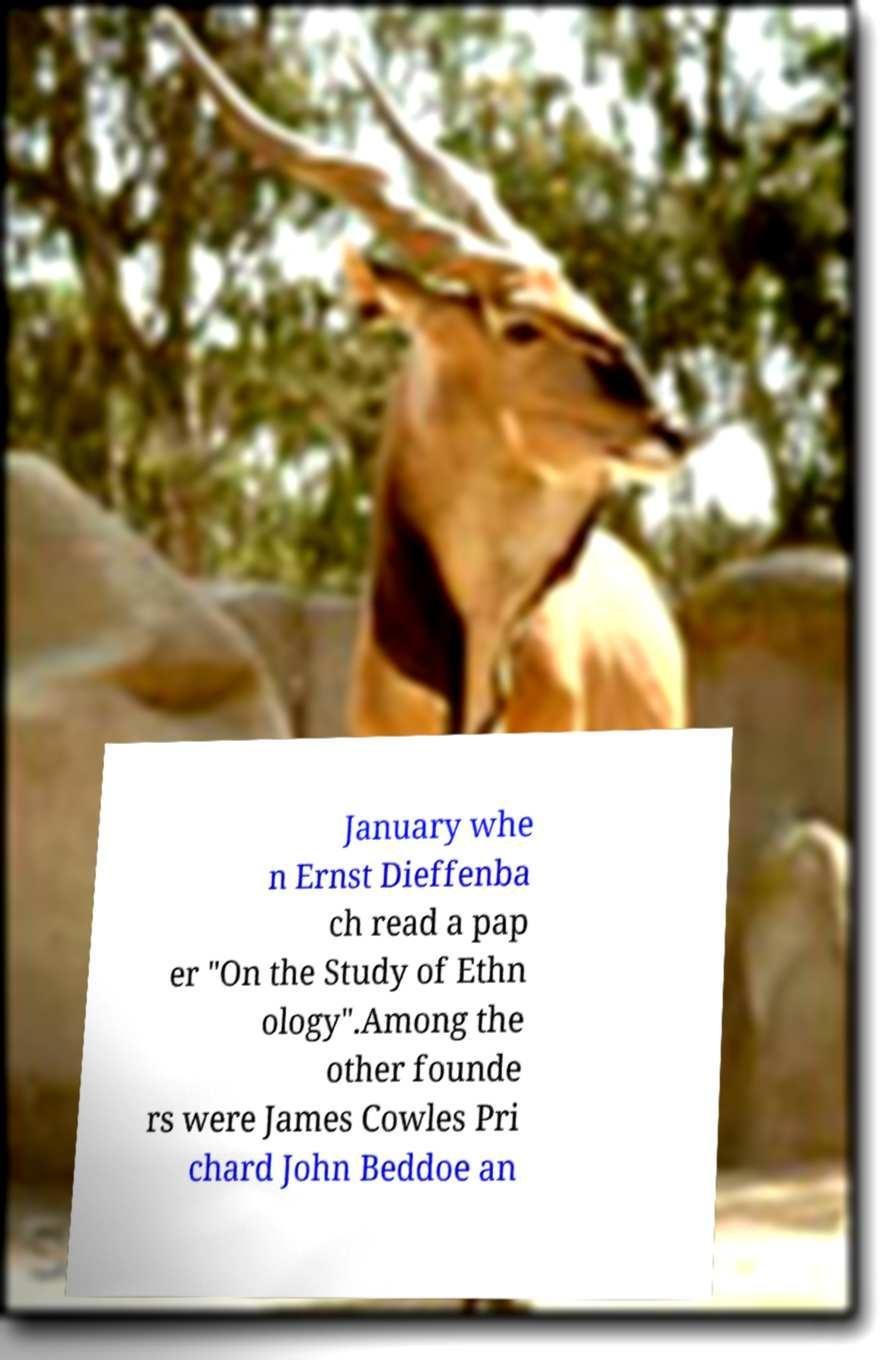Can you read and provide the text displayed in the image?This photo seems to have some interesting text. Can you extract and type it out for me? January whe n Ernst Dieffenba ch read a pap er "On the Study of Ethn ology".Among the other founde rs were James Cowles Pri chard John Beddoe an 